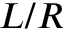<formula> <loc_0><loc_0><loc_500><loc_500>L / R</formula> 